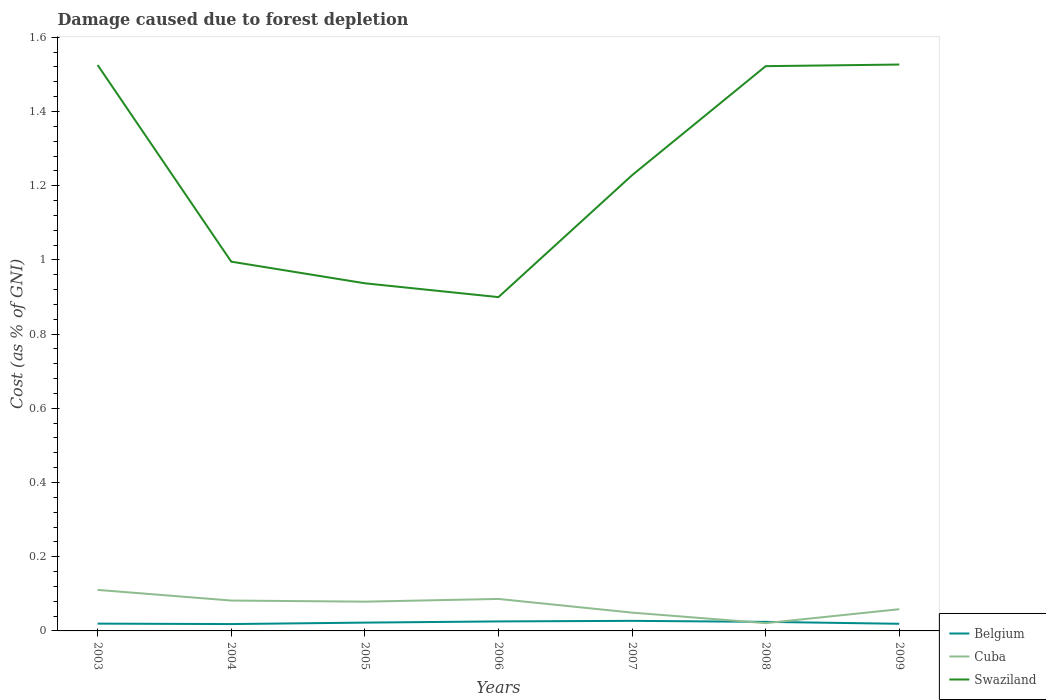How many different coloured lines are there?
Keep it short and to the point. 3. Across all years, what is the maximum cost of damage caused due to forest depletion in Swaziland?
Your response must be concise. 0.9. In which year was the cost of damage caused due to forest depletion in Swaziland maximum?
Give a very brief answer. 2006. What is the total cost of damage caused due to forest depletion in Cuba in the graph?
Ensure brevity in your answer.  0.06. What is the difference between the highest and the second highest cost of damage caused due to forest depletion in Swaziland?
Offer a terse response. 0.63. How many lines are there?
Provide a short and direct response. 3. Does the graph contain grids?
Provide a succinct answer. No. Where does the legend appear in the graph?
Your response must be concise. Bottom right. What is the title of the graph?
Offer a very short reply. Damage caused due to forest depletion. What is the label or title of the Y-axis?
Keep it short and to the point. Cost (as % of GNI). What is the Cost (as % of GNI) of Belgium in 2003?
Provide a succinct answer. 0.02. What is the Cost (as % of GNI) in Cuba in 2003?
Your answer should be compact. 0.11. What is the Cost (as % of GNI) of Swaziland in 2003?
Provide a succinct answer. 1.53. What is the Cost (as % of GNI) in Belgium in 2004?
Keep it short and to the point. 0.02. What is the Cost (as % of GNI) in Cuba in 2004?
Offer a terse response. 0.08. What is the Cost (as % of GNI) in Swaziland in 2004?
Provide a short and direct response. 1. What is the Cost (as % of GNI) of Belgium in 2005?
Your response must be concise. 0.02. What is the Cost (as % of GNI) in Cuba in 2005?
Offer a terse response. 0.08. What is the Cost (as % of GNI) of Swaziland in 2005?
Your response must be concise. 0.94. What is the Cost (as % of GNI) in Belgium in 2006?
Provide a short and direct response. 0.03. What is the Cost (as % of GNI) in Cuba in 2006?
Your answer should be compact. 0.09. What is the Cost (as % of GNI) of Swaziland in 2006?
Provide a short and direct response. 0.9. What is the Cost (as % of GNI) in Belgium in 2007?
Your answer should be compact. 0.03. What is the Cost (as % of GNI) of Cuba in 2007?
Provide a succinct answer. 0.05. What is the Cost (as % of GNI) of Swaziland in 2007?
Keep it short and to the point. 1.23. What is the Cost (as % of GNI) in Belgium in 2008?
Provide a short and direct response. 0.02. What is the Cost (as % of GNI) of Cuba in 2008?
Your answer should be compact. 0.02. What is the Cost (as % of GNI) of Swaziland in 2008?
Your answer should be very brief. 1.52. What is the Cost (as % of GNI) of Belgium in 2009?
Your response must be concise. 0.02. What is the Cost (as % of GNI) of Cuba in 2009?
Your answer should be very brief. 0.06. What is the Cost (as % of GNI) of Swaziland in 2009?
Keep it short and to the point. 1.53. Across all years, what is the maximum Cost (as % of GNI) of Belgium?
Your answer should be compact. 0.03. Across all years, what is the maximum Cost (as % of GNI) of Cuba?
Your answer should be compact. 0.11. Across all years, what is the maximum Cost (as % of GNI) of Swaziland?
Offer a terse response. 1.53. Across all years, what is the minimum Cost (as % of GNI) in Belgium?
Give a very brief answer. 0.02. Across all years, what is the minimum Cost (as % of GNI) of Cuba?
Your answer should be compact. 0.02. Across all years, what is the minimum Cost (as % of GNI) in Swaziland?
Provide a succinct answer. 0.9. What is the total Cost (as % of GNI) of Belgium in the graph?
Provide a short and direct response. 0.16. What is the total Cost (as % of GNI) of Cuba in the graph?
Provide a short and direct response. 0.49. What is the total Cost (as % of GNI) in Swaziland in the graph?
Offer a very short reply. 8.63. What is the difference between the Cost (as % of GNI) of Belgium in 2003 and that in 2004?
Keep it short and to the point. 0. What is the difference between the Cost (as % of GNI) in Cuba in 2003 and that in 2004?
Your answer should be compact. 0.03. What is the difference between the Cost (as % of GNI) of Swaziland in 2003 and that in 2004?
Provide a short and direct response. 0.53. What is the difference between the Cost (as % of GNI) of Belgium in 2003 and that in 2005?
Offer a terse response. -0. What is the difference between the Cost (as % of GNI) of Cuba in 2003 and that in 2005?
Offer a terse response. 0.03. What is the difference between the Cost (as % of GNI) of Swaziland in 2003 and that in 2005?
Give a very brief answer. 0.59. What is the difference between the Cost (as % of GNI) in Belgium in 2003 and that in 2006?
Make the answer very short. -0.01. What is the difference between the Cost (as % of GNI) of Cuba in 2003 and that in 2006?
Provide a succinct answer. 0.02. What is the difference between the Cost (as % of GNI) in Swaziland in 2003 and that in 2006?
Offer a very short reply. 0.63. What is the difference between the Cost (as % of GNI) of Belgium in 2003 and that in 2007?
Ensure brevity in your answer.  -0.01. What is the difference between the Cost (as % of GNI) of Cuba in 2003 and that in 2007?
Offer a terse response. 0.06. What is the difference between the Cost (as % of GNI) in Swaziland in 2003 and that in 2007?
Keep it short and to the point. 0.3. What is the difference between the Cost (as % of GNI) in Belgium in 2003 and that in 2008?
Offer a very short reply. -0. What is the difference between the Cost (as % of GNI) in Cuba in 2003 and that in 2008?
Your answer should be very brief. 0.09. What is the difference between the Cost (as % of GNI) in Swaziland in 2003 and that in 2008?
Keep it short and to the point. 0. What is the difference between the Cost (as % of GNI) in Cuba in 2003 and that in 2009?
Your response must be concise. 0.05. What is the difference between the Cost (as % of GNI) of Swaziland in 2003 and that in 2009?
Provide a short and direct response. -0. What is the difference between the Cost (as % of GNI) in Belgium in 2004 and that in 2005?
Give a very brief answer. -0. What is the difference between the Cost (as % of GNI) of Cuba in 2004 and that in 2005?
Your answer should be compact. 0. What is the difference between the Cost (as % of GNI) of Swaziland in 2004 and that in 2005?
Your response must be concise. 0.06. What is the difference between the Cost (as % of GNI) in Belgium in 2004 and that in 2006?
Give a very brief answer. -0.01. What is the difference between the Cost (as % of GNI) in Cuba in 2004 and that in 2006?
Keep it short and to the point. -0. What is the difference between the Cost (as % of GNI) in Swaziland in 2004 and that in 2006?
Your response must be concise. 0.1. What is the difference between the Cost (as % of GNI) in Belgium in 2004 and that in 2007?
Provide a succinct answer. -0.01. What is the difference between the Cost (as % of GNI) in Cuba in 2004 and that in 2007?
Offer a terse response. 0.03. What is the difference between the Cost (as % of GNI) of Swaziland in 2004 and that in 2007?
Your response must be concise. -0.23. What is the difference between the Cost (as % of GNI) in Belgium in 2004 and that in 2008?
Keep it short and to the point. -0.01. What is the difference between the Cost (as % of GNI) in Cuba in 2004 and that in 2008?
Provide a short and direct response. 0.06. What is the difference between the Cost (as % of GNI) in Swaziland in 2004 and that in 2008?
Your response must be concise. -0.53. What is the difference between the Cost (as % of GNI) in Belgium in 2004 and that in 2009?
Keep it short and to the point. -0. What is the difference between the Cost (as % of GNI) of Cuba in 2004 and that in 2009?
Your response must be concise. 0.02. What is the difference between the Cost (as % of GNI) of Swaziland in 2004 and that in 2009?
Offer a very short reply. -0.53. What is the difference between the Cost (as % of GNI) in Belgium in 2005 and that in 2006?
Your answer should be very brief. -0. What is the difference between the Cost (as % of GNI) of Cuba in 2005 and that in 2006?
Your response must be concise. -0.01. What is the difference between the Cost (as % of GNI) of Swaziland in 2005 and that in 2006?
Keep it short and to the point. 0.04. What is the difference between the Cost (as % of GNI) of Belgium in 2005 and that in 2007?
Ensure brevity in your answer.  -0. What is the difference between the Cost (as % of GNI) in Cuba in 2005 and that in 2007?
Ensure brevity in your answer.  0.03. What is the difference between the Cost (as % of GNI) in Swaziland in 2005 and that in 2007?
Your answer should be compact. -0.29. What is the difference between the Cost (as % of GNI) of Belgium in 2005 and that in 2008?
Offer a terse response. -0. What is the difference between the Cost (as % of GNI) of Cuba in 2005 and that in 2008?
Keep it short and to the point. 0.06. What is the difference between the Cost (as % of GNI) in Swaziland in 2005 and that in 2008?
Your answer should be compact. -0.59. What is the difference between the Cost (as % of GNI) of Belgium in 2005 and that in 2009?
Ensure brevity in your answer.  0. What is the difference between the Cost (as % of GNI) in Cuba in 2005 and that in 2009?
Provide a short and direct response. 0.02. What is the difference between the Cost (as % of GNI) in Swaziland in 2005 and that in 2009?
Provide a short and direct response. -0.59. What is the difference between the Cost (as % of GNI) in Belgium in 2006 and that in 2007?
Offer a terse response. -0. What is the difference between the Cost (as % of GNI) in Cuba in 2006 and that in 2007?
Give a very brief answer. 0.04. What is the difference between the Cost (as % of GNI) in Swaziland in 2006 and that in 2007?
Your answer should be compact. -0.33. What is the difference between the Cost (as % of GNI) of Belgium in 2006 and that in 2008?
Offer a very short reply. 0. What is the difference between the Cost (as % of GNI) of Cuba in 2006 and that in 2008?
Give a very brief answer. 0.07. What is the difference between the Cost (as % of GNI) of Swaziland in 2006 and that in 2008?
Provide a short and direct response. -0.62. What is the difference between the Cost (as % of GNI) in Belgium in 2006 and that in 2009?
Your answer should be compact. 0.01. What is the difference between the Cost (as % of GNI) of Cuba in 2006 and that in 2009?
Your answer should be very brief. 0.03. What is the difference between the Cost (as % of GNI) of Swaziland in 2006 and that in 2009?
Provide a succinct answer. -0.63. What is the difference between the Cost (as % of GNI) of Belgium in 2007 and that in 2008?
Your answer should be compact. 0. What is the difference between the Cost (as % of GNI) in Cuba in 2007 and that in 2008?
Keep it short and to the point. 0.03. What is the difference between the Cost (as % of GNI) in Swaziland in 2007 and that in 2008?
Your answer should be very brief. -0.29. What is the difference between the Cost (as % of GNI) of Belgium in 2007 and that in 2009?
Your answer should be compact. 0.01. What is the difference between the Cost (as % of GNI) in Cuba in 2007 and that in 2009?
Ensure brevity in your answer.  -0.01. What is the difference between the Cost (as % of GNI) of Swaziland in 2007 and that in 2009?
Your answer should be very brief. -0.3. What is the difference between the Cost (as % of GNI) of Belgium in 2008 and that in 2009?
Ensure brevity in your answer.  0.01. What is the difference between the Cost (as % of GNI) of Cuba in 2008 and that in 2009?
Keep it short and to the point. -0.04. What is the difference between the Cost (as % of GNI) in Swaziland in 2008 and that in 2009?
Provide a succinct answer. -0. What is the difference between the Cost (as % of GNI) of Belgium in 2003 and the Cost (as % of GNI) of Cuba in 2004?
Offer a very short reply. -0.06. What is the difference between the Cost (as % of GNI) of Belgium in 2003 and the Cost (as % of GNI) of Swaziland in 2004?
Give a very brief answer. -0.98. What is the difference between the Cost (as % of GNI) in Cuba in 2003 and the Cost (as % of GNI) in Swaziland in 2004?
Provide a short and direct response. -0.88. What is the difference between the Cost (as % of GNI) in Belgium in 2003 and the Cost (as % of GNI) in Cuba in 2005?
Offer a terse response. -0.06. What is the difference between the Cost (as % of GNI) in Belgium in 2003 and the Cost (as % of GNI) in Swaziland in 2005?
Keep it short and to the point. -0.92. What is the difference between the Cost (as % of GNI) of Cuba in 2003 and the Cost (as % of GNI) of Swaziland in 2005?
Make the answer very short. -0.83. What is the difference between the Cost (as % of GNI) in Belgium in 2003 and the Cost (as % of GNI) in Cuba in 2006?
Your response must be concise. -0.07. What is the difference between the Cost (as % of GNI) of Belgium in 2003 and the Cost (as % of GNI) of Swaziland in 2006?
Provide a short and direct response. -0.88. What is the difference between the Cost (as % of GNI) of Cuba in 2003 and the Cost (as % of GNI) of Swaziland in 2006?
Offer a very short reply. -0.79. What is the difference between the Cost (as % of GNI) in Belgium in 2003 and the Cost (as % of GNI) in Cuba in 2007?
Keep it short and to the point. -0.03. What is the difference between the Cost (as % of GNI) of Belgium in 2003 and the Cost (as % of GNI) of Swaziland in 2007?
Ensure brevity in your answer.  -1.21. What is the difference between the Cost (as % of GNI) of Cuba in 2003 and the Cost (as % of GNI) of Swaziland in 2007?
Give a very brief answer. -1.12. What is the difference between the Cost (as % of GNI) of Belgium in 2003 and the Cost (as % of GNI) of Cuba in 2008?
Offer a terse response. -0. What is the difference between the Cost (as % of GNI) in Belgium in 2003 and the Cost (as % of GNI) in Swaziland in 2008?
Offer a very short reply. -1.5. What is the difference between the Cost (as % of GNI) in Cuba in 2003 and the Cost (as % of GNI) in Swaziland in 2008?
Keep it short and to the point. -1.41. What is the difference between the Cost (as % of GNI) in Belgium in 2003 and the Cost (as % of GNI) in Cuba in 2009?
Offer a terse response. -0.04. What is the difference between the Cost (as % of GNI) of Belgium in 2003 and the Cost (as % of GNI) of Swaziland in 2009?
Your response must be concise. -1.51. What is the difference between the Cost (as % of GNI) in Cuba in 2003 and the Cost (as % of GNI) in Swaziland in 2009?
Offer a very short reply. -1.42. What is the difference between the Cost (as % of GNI) in Belgium in 2004 and the Cost (as % of GNI) in Cuba in 2005?
Provide a short and direct response. -0.06. What is the difference between the Cost (as % of GNI) in Belgium in 2004 and the Cost (as % of GNI) in Swaziland in 2005?
Your answer should be compact. -0.92. What is the difference between the Cost (as % of GNI) in Cuba in 2004 and the Cost (as % of GNI) in Swaziland in 2005?
Offer a terse response. -0.86. What is the difference between the Cost (as % of GNI) in Belgium in 2004 and the Cost (as % of GNI) in Cuba in 2006?
Offer a terse response. -0.07. What is the difference between the Cost (as % of GNI) in Belgium in 2004 and the Cost (as % of GNI) in Swaziland in 2006?
Your answer should be compact. -0.88. What is the difference between the Cost (as % of GNI) in Cuba in 2004 and the Cost (as % of GNI) in Swaziland in 2006?
Your answer should be compact. -0.82. What is the difference between the Cost (as % of GNI) of Belgium in 2004 and the Cost (as % of GNI) of Cuba in 2007?
Offer a terse response. -0.03. What is the difference between the Cost (as % of GNI) in Belgium in 2004 and the Cost (as % of GNI) in Swaziland in 2007?
Offer a very short reply. -1.21. What is the difference between the Cost (as % of GNI) in Cuba in 2004 and the Cost (as % of GNI) in Swaziland in 2007?
Keep it short and to the point. -1.15. What is the difference between the Cost (as % of GNI) of Belgium in 2004 and the Cost (as % of GNI) of Cuba in 2008?
Offer a very short reply. -0. What is the difference between the Cost (as % of GNI) in Belgium in 2004 and the Cost (as % of GNI) in Swaziland in 2008?
Make the answer very short. -1.5. What is the difference between the Cost (as % of GNI) in Cuba in 2004 and the Cost (as % of GNI) in Swaziland in 2008?
Your answer should be very brief. -1.44. What is the difference between the Cost (as % of GNI) in Belgium in 2004 and the Cost (as % of GNI) in Cuba in 2009?
Your answer should be very brief. -0.04. What is the difference between the Cost (as % of GNI) in Belgium in 2004 and the Cost (as % of GNI) in Swaziland in 2009?
Offer a very short reply. -1.51. What is the difference between the Cost (as % of GNI) in Cuba in 2004 and the Cost (as % of GNI) in Swaziland in 2009?
Offer a very short reply. -1.44. What is the difference between the Cost (as % of GNI) of Belgium in 2005 and the Cost (as % of GNI) of Cuba in 2006?
Provide a succinct answer. -0.06. What is the difference between the Cost (as % of GNI) in Belgium in 2005 and the Cost (as % of GNI) in Swaziland in 2006?
Give a very brief answer. -0.88. What is the difference between the Cost (as % of GNI) in Cuba in 2005 and the Cost (as % of GNI) in Swaziland in 2006?
Make the answer very short. -0.82. What is the difference between the Cost (as % of GNI) of Belgium in 2005 and the Cost (as % of GNI) of Cuba in 2007?
Offer a terse response. -0.03. What is the difference between the Cost (as % of GNI) in Belgium in 2005 and the Cost (as % of GNI) in Swaziland in 2007?
Provide a succinct answer. -1.21. What is the difference between the Cost (as % of GNI) in Cuba in 2005 and the Cost (as % of GNI) in Swaziland in 2007?
Ensure brevity in your answer.  -1.15. What is the difference between the Cost (as % of GNI) in Belgium in 2005 and the Cost (as % of GNI) in Cuba in 2008?
Your answer should be compact. 0. What is the difference between the Cost (as % of GNI) in Belgium in 2005 and the Cost (as % of GNI) in Swaziland in 2008?
Make the answer very short. -1.5. What is the difference between the Cost (as % of GNI) in Cuba in 2005 and the Cost (as % of GNI) in Swaziland in 2008?
Ensure brevity in your answer.  -1.44. What is the difference between the Cost (as % of GNI) in Belgium in 2005 and the Cost (as % of GNI) in Cuba in 2009?
Ensure brevity in your answer.  -0.04. What is the difference between the Cost (as % of GNI) of Belgium in 2005 and the Cost (as % of GNI) of Swaziland in 2009?
Offer a very short reply. -1.5. What is the difference between the Cost (as % of GNI) in Cuba in 2005 and the Cost (as % of GNI) in Swaziland in 2009?
Offer a terse response. -1.45. What is the difference between the Cost (as % of GNI) in Belgium in 2006 and the Cost (as % of GNI) in Cuba in 2007?
Give a very brief answer. -0.02. What is the difference between the Cost (as % of GNI) of Belgium in 2006 and the Cost (as % of GNI) of Swaziland in 2007?
Keep it short and to the point. -1.2. What is the difference between the Cost (as % of GNI) in Cuba in 2006 and the Cost (as % of GNI) in Swaziland in 2007?
Give a very brief answer. -1.14. What is the difference between the Cost (as % of GNI) of Belgium in 2006 and the Cost (as % of GNI) of Cuba in 2008?
Give a very brief answer. 0. What is the difference between the Cost (as % of GNI) in Belgium in 2006 and the Cost (as % of GNI) in Swaziland in 2008?
Keep it short and to the point. -1.5. What is the difference between the Cost (as % of GNI) of Cuba in 2006 and the Cost (as % of GNI) of Swaziland in 2008?
Keep it short and to the point. -1.44. What is the difference between the Cost (as % of GNI) of Belgium in 2006 and the Cost (as % of GNI) of Cuba in 2009?
Provide a short and direct response. -0.03. What is the difference between the Cost (as % of GNI) of Belgium in 2006 and the Cost (as % of GNI) of Swaziland in 2009?
Give a very brief answer. -1.5. What is the difference between the Cost (as % of GNI) of Cuba in 2006 and the Cost (as % of GNI) of Swaziland in 2009?
Keep it short and to the point. -1.44. What is the difference between the Cost (as % of GNI) of Belgium in 2007 and the Cost (as % of GNI) of Cuba in 2008?
Ensure brevity in your answer.  0.01. What is the difference between the Cost (as % of GNI) of Belgium in 2007 and the Cost (as % of GNI) of Swaziland in 2008?
Provide a succinct answer. -1.5. What is the difference between the Cost (as % of GNI) in Cuba in 2007 and the Cost (as % of GNI) in Swaziland in 2008?
Your response must be concise. -1.47. What is the difference between the Cost (as % of GNI) of Belgium in 2007 and the Cost (as % of GNI) of Cuba in 2009?
Your response must be concise. -0.03. What is the difference between the Cost (as % of GNI) in Belgium in 2007 and the Cost (as % of GNI) in Swaziland in 2009?
Offer a very short reply. -1.5. What is the difference between the Cost (as % of GNI) in Cuba in 2007 and the Cost (as % of GNI) in Swaziland in 2009?
Keep it short and to the point. -1.48. What is the difference between the Cost (as % of GNI) of Belgium in 2008 and the Cost (as % of GNI) of Cuba in 2009?
Keep it short and to the point. -0.03. What is the difference between the Cost (as % of GNI) in Belgium in 2008 and the Cost (as % of GNI) in Swaziland in 2009?
Your answer should be compact. -1.5. What is the difference between the Cost (as % of GNI) in Cuba in 2008 and the Cost (as % of GNI) in Swaziland in 2009?
Your response must be concise. -1.51. What is the average Cost (as % of GNI) of Belgium per year?
Ensure brevity in your answer.  0.02. What is the average Cost (as % of GNI) in Cuba per year?
Your answer should be very brief. 0.07. What is the average Cost (as % of GNI) of Swaziland per year?
Ensure brevity in your answer.  1.23. In the year 2003, what is the difference between the Cost (as % of GNI) in Belgium and Cost (as % of GNI) in Cuba?
Offer a terse response. -0.09. In the year 2003, what is the difference between the Cost (as % of GNI) in Belgium and Cost (as % of GNI) in Swaziland?
Ensure brevity in your answer.  -1.51. In the year 2003, what is the difference between the Cost (as % of GNI) of Cuba and Cost (as % of GNI) of Swaziland?
Give a very brief answer. -1.41. In the year 2004, what is the difference between the Cost (as % of GNI) of Belgium and Cost (as % of GNI) of Cuba?
Offer a terse response. -0.06. In the year 2004, what is the difference between the Cost (as % of GNI) of Belgium and Cost (as % of GNI) of Swaziland?
Make the answer very short. -0.98. In the year 2004, what is the difference between the Cost (as % of GNI) in Cuba and Cost (as % of GNI) in Swaziland?
Offer a terse response. -0.91. In the year 2005, what is the difference between the Cost (as % of GNI) of Belgium and Cost (as % of GNI) of Cuba?
Provide a succinct answer. -0.06. In the year 2005, what is the difference between the Cost (as % of GNI) of Belgium and Cost (as % of GNI) of Swaziland?
Make the answer very short. -0.91. In the year 2005, what is the difference between the Cost (as % of GNI) of Cuba and Cost (as % of GNI) of Swaziland?
Ensure brevity in your answer.  -0.86. In the year 2006, what is the difference between the Cost (as % of GNI) in Belgium and Cost (as % of GNI) in Cuba?
Your answer should be very brief. -0.06. In the year 2006, what is the difference between the Cost (as % of GNI) of Belgium and Cost (as % of GNI) of Swaziland?
Your response must be concise. -0.87. In the year 2006, what is the difference between the Cost (as % of GNI) in Cuba and Cost (as % of GNI) in Swaziland?
Your answer should be very brief. -0.81. In the year 2007, what is the difference between the Cost (as % of GNI) in Belgium and Cost (as % of GNI) in Cuba?
Your answer should be very brief. -0.02. In the year 2007, what is the difference between the Cost (as % of GNI) of Belgium and Cost (as % of GNI) of Swaziland?
Give a very brief answer. -1.2. In the year 2007, what is the difference between the Cost (as % of GNI) in Cuba and Cost (as % of GNI) in Swaziland?
Your response must be concise. -1.18. In the year 2008, what is the difference between the Cost (as % of GNI) of Belgium and Cost (as % of GNI) of Cuba?
Offer a terse response. 0. In the year 2008, what is the difference between the Cost (as % of GNI) in Belgium and Cost (as % of GNI) in Swaziland?
Offer a terse response. -1.5. In the year 2008, what is the difference between the Cost (as % of GNI) in Cuba and Cost (as % of GNI) in Swaziland?
Make the answer very short. -1.5. In the year 2009, what is the difference between the Cost (as % of GNI) of Belgium and Cost (as % of GNI) of Cuba?
Ensure brevity in your answer.  -0.04. In the year 2009, what is the difference between the Cost (as % of GNI) in Belgium and Cost (as % of GNI) in Swaziland?
Make the answer very short. -1.51. In the year 2009, what is the difference between the Cost (as % of GNI) of Cuba and Cost (as % of GNI) of Swaziland?
Offer a terse response. -1.47. What is the ratio of the Cost (as % of GNI) of Belgium in 2003 to that in 2004?
Provide a short and direct response. 1.06. What is the ratio of the Cost (as % of GNI) of Cuba in 2003 to that in 2004?
Provide a short and direct response. 1.35. What is the ratio of the Cost (as % of GNI) in Swaziland in 2003 to that in 2004?
Your answer should be very brief. 1.53. What is the ratio of the Cost (as % of GNI) in Belgium in 2003 to that in 2005?
Provide a short and direct response. 0.88. What is the ratio of the Cost (as % of GNI) in Cuba in 2003 to that in 2005?
Provide a short and direct response. 1.4. What is the ratio of the Cost (as % of GNI) in Swaziland in 2003 to that in 2005?
Keep it short and to the point. 1.63. What is the ratio of the Cost (as % of GNI) of Belgium in 2003 to that in 2006?
Keep it short and to the point. 0.77. What is the ratio of the Cost (as % of GNI) of Cuba in 2003 to that in 2006?
Keep it short and to the point. 1.28. What is the ratio of the Cost (as % of GNI) of Swaziland in 2003 to that in 2006?
Provide a short and direct response. 1.7. What is the ratio of the Cost (as % of GNI) of Belgium in 2003 to that in 2007?
Ensure brevity in your answer.  0.72. What is the ratio of the Cost (as % of GNI) of Cuba in 2003 to that in 2007?
Offer a very short reply. 2.24. What is the ratio of the Cost (as % of GNI) of Swaziland in 2003 to that in 2007?
Make the answer very short. 1.24. What is the ratio of the Cost (as % of GNI) of Belgium in 2003 to that in 2008?
Your answer should be compact. 0.81. What is the ratio of the Cost (as % of GNI) in Cuba in 2003 to that in 2008?
Your response must be concise. 5.27. What is the ratio of the Cost (as % of GNI) in Swaziland in 2003 to that in 2008?
Offer a terse response. 1. What is the ratio of the Cost (as % of GNI) in Belgium in 2003 to that in 2009?
Offer a terse response. 1.02. What is the ratio of the Cost (as % of GNI) in Cuba in 2003 to that in 2009?
Your answer should be compact. 1.89. What is the ratio of the Cost (as % of GNI) in Swaziland in 2003 to that in 2009?
Provide a short and direct response. 1. What is the ratio of the Cost (as % of GNI) of Belgium in 2004 to that in 2005?
Offer a very short reply. 0.82. What is the ratio of the Cost (as % of GNI) of Cuba in 2004 to that in 2005?
Your response must be concise. 1.04. What is the ratio of the Cost (as % of GNI) in Swaziland in 2004 to that in 2005?
Provide a succinct answer. 1.06. What is the ratio of the Cost (as % of GNI) of Belgium in 2004 to that in 2006?
Your answer should be compact. 0.72. What is the ratio of the Cost (as % of GNI) of Cuba in 2004 to that in 2006?
Your response must be concise. 0.95. What is the ratio of the Cost (as % of GNI) of Swaziland in 2004 to that in 2006?
Offer a terse response. 1.11. What is the ratio of the Cost (as % of GNI) of Belgium in 2004 to that in 2007?
Provide a succinct answer. 0.68. What is the ratio of the Cost (as % of GNI) in Cuba in 2004 to that in 2007?
Make the answer very short. 1.66. What is the ratio of the Cost (as % of GNI) of Swaziland in 2004 to that in 2007?
Provide a short and direct response. 0.81. What is the ratio of the Cost (as % of GNI) of Belgium in 2004 to that in 2008?
Offer a terse response. 0.76. What is the ratio of the Cost (as % of GNI) in Cuba in 2004 to that in 2008?
Your answer should be compact. 3.9. What is the ratio of the Cost (as % of GNI) in Swaziland in 2004 to that in 2008?
Offer a terse response. 0.65. What is the ratio of the Cost (as % of GNI) in Belgium in 2004 to that in 2009?
Offer a terse response. 0.96. What is the ratio of the Cost (as % of GNI) in Cuba in 2004 to that in 2009?
Keep it short and to the point. 1.4. What is the ratio of the Cost (as % of GNI) of Swaziland in 2004 to that in 2009?
Make the answer very short. 0.65. What is the ratio of the Cost (as % of GNI) of Belgium in 2005 to that in 2006?
Provide a short and direct response. 0.88. What is the ratio of the Cost (as % of GNI) in Cuba in 2005 to that in 2006?
Keep it short and to the point. 0.92. What is the ratio of the Cost (as % of GNI) of Swaziland in 2005 to that in 2006?
Keep it short and to the point. 1.04. What is the ratio of the Cost (as % of GNI) in Belgium in 2005 to that in 2007?
Your answer should be compact. 0.82. What is the ratio of the Cost (as % of GNI) in Cuba in 2005 to that in 2007?
Your response must be concise. 1.6. What is the ratio of the Cost (as % of GNI) in Swaziland in 2005 to that in 2007?
Your answer should be very brief. 0.76. What is the ratio of the Cost (as % of GNI) of Belgium in 2005 to that in 2008?
Your answer should be compact. 0.92. What is the ratio of the Cost (as % of GNI) in Cuba in 2005 to that in 2008?
Your answer should be compact. 3.76. What is the ratio of the Cost (as % of GNI) in Swaziland in 2005 to that in 2008?
Ensure brevity in your answer.  0.62. What is the ratio of the Cost (as % of GNI) in Belgium in 2005 to that in 2009?
Keep it short and to the point. 1.17. What is the ratio of the Cost (as % of GNI) in Cuba in 2005 to that in 2009?
Your response must be concise. 1.35. What is the ratio of the Cost (as % of GNI) of Swaziland in 2005 to that in 2009?
Offer a terse response. 0.61. What is the ratio of the Cost (as % of GNI) in Belgium in 2006 to that in 2007?
Keep it short and to the point. 0.94. What is the ratio of the Cost (as % of GNI) of Cuba in 2006 to that in 2007?
Keep it short and to the point. 1.75. What is the ratio of the Cost (as % of GNI) of Swaziland in 2006 to that in 2007?
Keep it short and to the point. 0.73. What is the ratio of the Cost (as % of GNI) in Belgium in 2006 to that in 2008?
Ensure brevity in your answer.  1.05. What is the ratio of the Cost (as % of GNI) of Cuba in 2006 to that in 2008?
Give a very brief answer. 4.11. What is the ratio of the Cost (as % of GNI) in Swaziland in 2006 to that in 2008?
Give a very brief answer. 0.59. What is the ratio of the Cost (as % of GNI) in Belgium in 2006 to that in 2009?
Your answer should be compact. 1.33. What is the ratio of the Cost (as % of GNI) of Cuba in 2006 to that in 2009?
Provide a succinct answer. 1.47. What is the ratio of the Cost (as % of GNI) of Swaziland in 2006 to that in 2009?
Your response must be concise. 0.59. What is the ratio of the Cost (as % of GNI) of Belgium in 2007 to that in 2008?
Your answer should be very brief. 1.11. What is the ratio of the Cost (as % of GNI) in Cuba in 2007 to that in 2008?
Offer a terse response. 2.35. What is the ratio of the Cost (as % of GNI) of Swaziland in 2007 to that in 2008?
Your answer should be very brief. 0.81. What is the ratio of the Cost (as % of GNI) in Belgium in 2007 to that in 2009?
Make the answer very short. 1.41. What is the ratio of the Cost (as % of GNI) of Cuba in 2007 to that in 2009?
Offer a terse response. 0.84. What is the ratio of the Cost (as % of GNI) in Swaziland in 2007 to that in 2009?
Offer a terse response. 0.8. What is the ratio of the Cost (as % of GNI) of Belgium in 2008 to that in 2009?
Provide a short and direct response. 1.27. What is the ratio of the Cost (as % of GNI) in Cuba in 2008 to that in 2009?
Keep it short and to the point. 0.36. What is the difference between the highest and the second highest Cost (as % of GNI) of Belgium?
Your answer should be very brief. 0. What is the difference between the highest and the second highest Cost (as % of GNI) in Cuba?
Your response must be concise. 0.02. What is the difference between the highest and the second highest Cost (as % of GNI) in Swaziland?
Keep it short and to the point. 0. What is the difference between the highest and the lowest Cost (as % of GNI) of Belgium?
Your response must be concise. 0.01. What is the difference between the highest and the lowest Cost (as % of GNI) in Cuba?
Provide a short and direct response. 0.09. What is the difference between the highest and the lowest Cost (as % of GNI) of Swaziland?
Give a very brief answer. 0.63. 